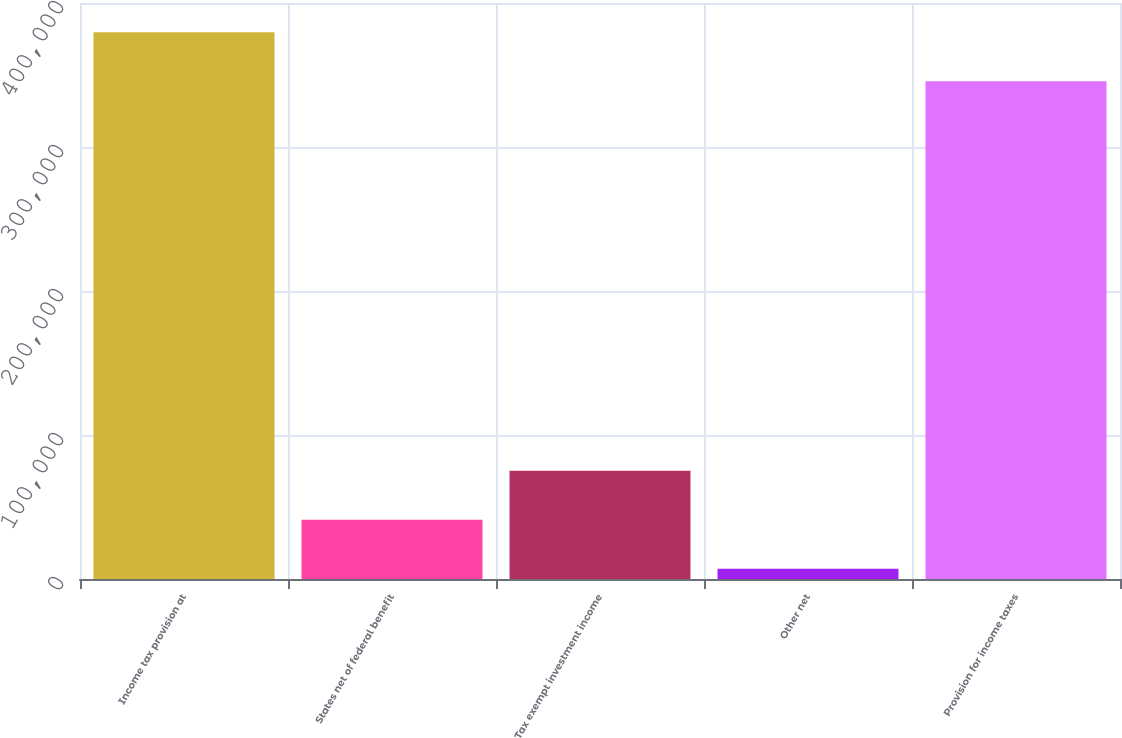Convert chart to OTSL. <chart><loc_0><loc_0><loc_500><loc_500><bar_chart><fcel>Income tax provision at<fcel>States net of federal benefit<fcel>Tax exempt investment income<fcel>Other net<fcel>Provision for income taxes<nl><fcel>379740<fcel>41083.9<fcel>75129.8<fcel>7038<fcel>345694<nl></chart> 